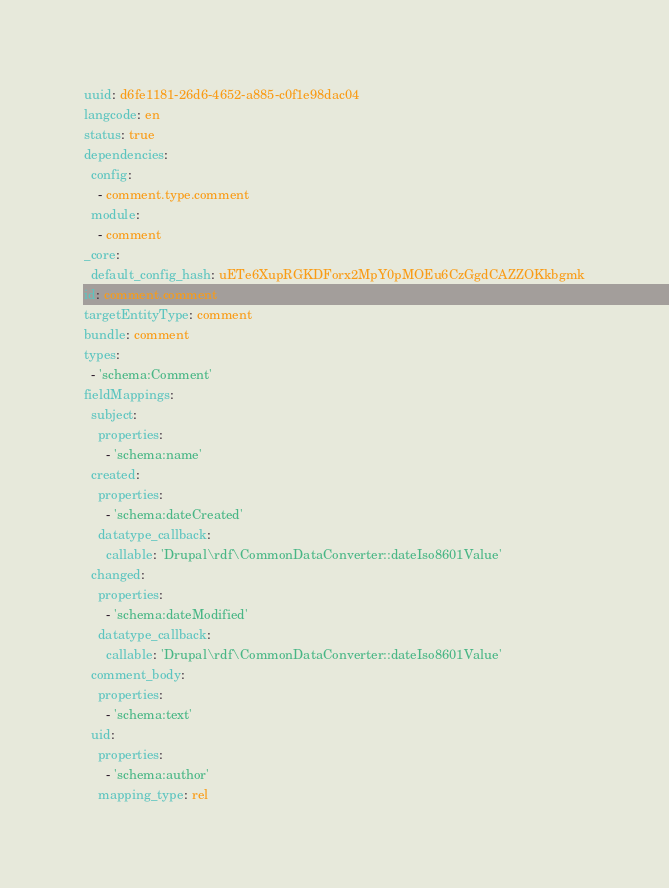Convert code to text. <code><loc_0><loc_0><loc_500><loc_500><_YAML_>uuid: d6fe1181-26d6-4652-a885-c0f1e98dac04
langcode: en
status: true
dependencies:
  config:
    - comment.type.comment
  module:
    - comment
_core:
  default_config_hash: uETe6XupRGKDForx2MpY0pMOEu6CzGgdCAZZOKkbgmk
id: comment.comment
targetEntityType: comment
bundle: comment
types:
  - 'schema:Comment'
fieldMappings:
  subject:
    properties:
      - 'schema:name'
  created:
    properties:
      - 'schema:dateCreated'
    datatype_callback:
      callable: 'Drupal\rdf\CommonDataConverter::dateIso8601Value'
  changed:
    properties:
      - 'schema:dateModified'
    datatype_callback:
      callable: 'Drupal\rdf\CommonDataConverter::dateIso8601Value'
  comment_body:
    properties:
      - 'schema:text'
  uid:
    properties:
      - 'schema:author'
    mapping_type: rel
</code> 